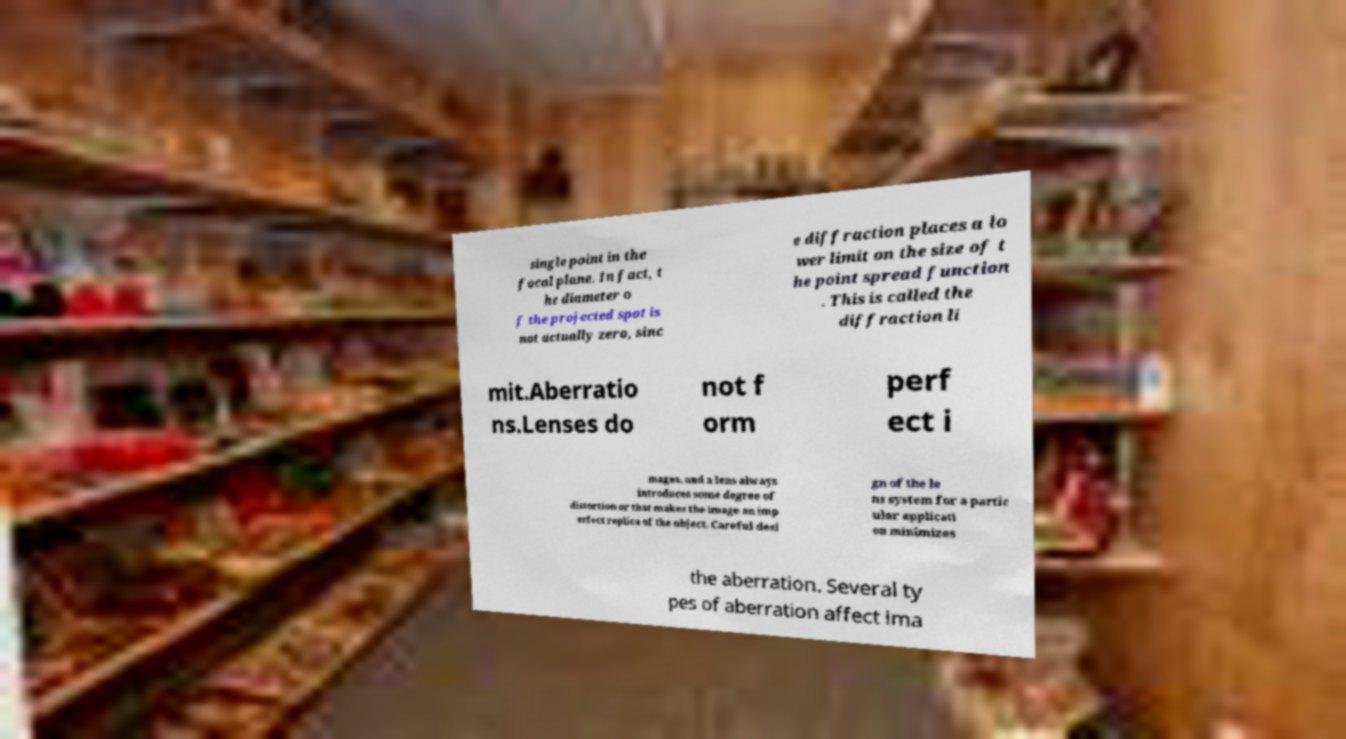Please read and relay the text visible in this image. What does it say? single point in the focal plane. In fact, t he diameter o f the projected spot is not actually zero, sinc e diffraction places a lo wer limit on the size of t he point spread function . This is called the diffraction li mit.Aberratio ns.Lenses do not f orm perf ect i mages, and a lens always introduces some degree of distortion or that makes the image an imp erfect replica of the object. Careful desi gn of the le ns system for a partic ular applicati on minimizes the aberration. Several ty pes of aberration affect ima 